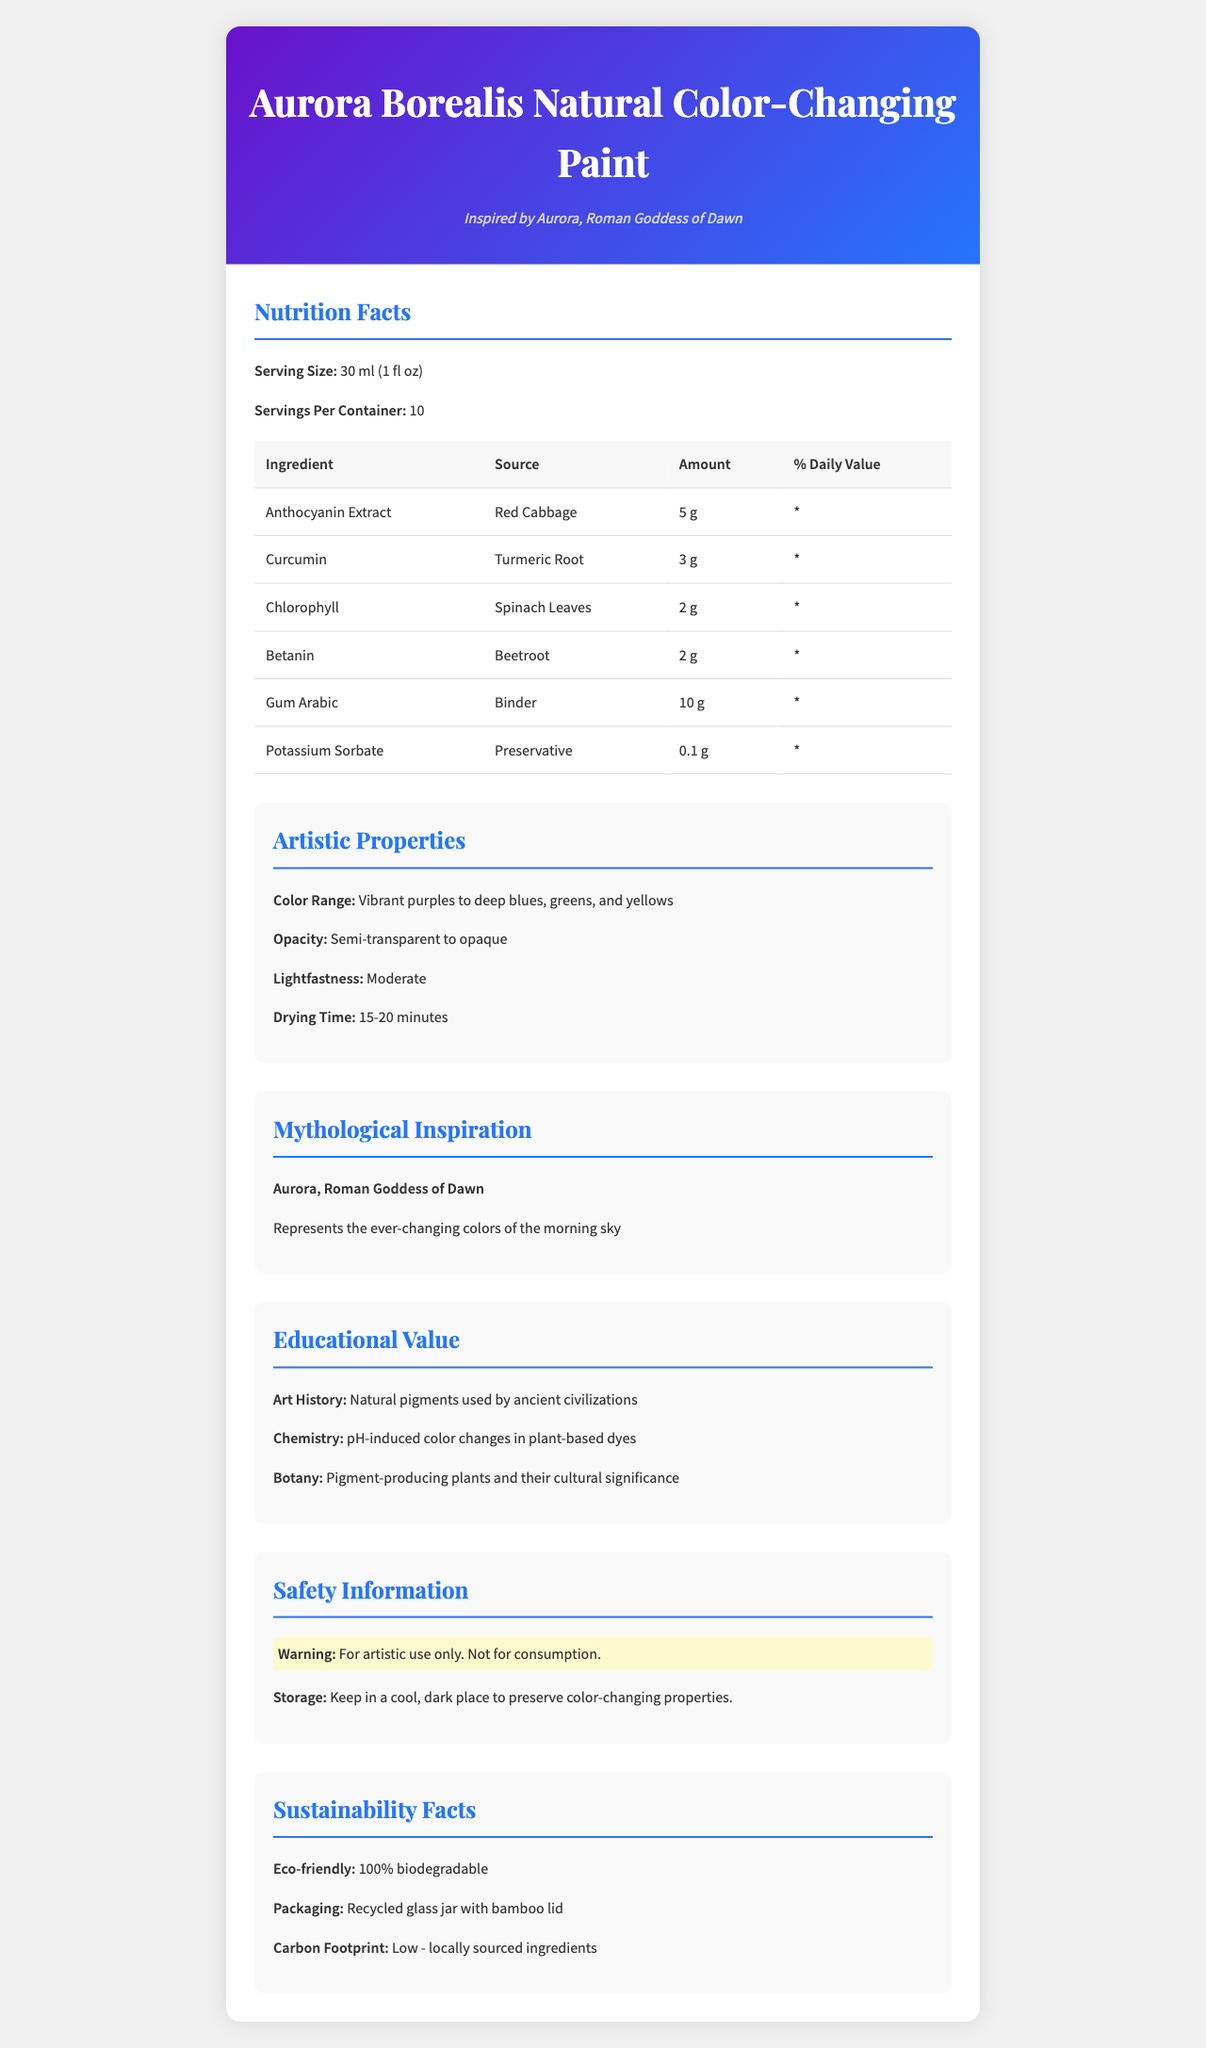what is the serving size? The serving size is explicitly mentioned at the beginning of the document under "Serving Size".
Answer: 30 ml (1 fl oz) how many servings are there per container? The document states the number of servings per container, which is 10.
Answer: 10 name one natural source of the pigment Anthocyanin Extract. The source for Anthocyanin Extract is mentioned as Red Cabbage in the pigment composition table.
Answer: Red Cabbage what is the drying time of the paint? The drying time is listed under "Artistic Properties".
Answer: 15-20 minutes who is the mythological inspiration for the paint? The mythological inspiration is Aurora, the Roman Goddess of Dawn, detailed under "Mythological Inspiration".
Answer: Aurora, Roman Goddess of Dawn which pigment is sourced from Turmeric Root? Curcumin is listed with Turmeric Root as its source in the pigment composition.
Answer: Curcumin what is the main binder used in this paint? Gum Arabic is mentioned as the binder in the pigment composition table.
Answer: Gum Arabic how many grams of Curcumin are in each serving? The amount of Curcumin per serving is 3 g, as listed in the pigment composition.
Answer: 3 g what educational topics are explored through this product? A. Art History B. Chemistry C. Botany D. All of the above The document details educational values in art history, chemistry, and botany.
Answer: D which of the following ingredients is a preservative? A. Citric Acid B. Potassium Sorbate C. Sodium Bicarbonate D. Gum Arabic Potassium Sorbate is listed as the preservative with the amount and percent daily value in the pigment composition.
Answer: B does the document suggest the paint is safe for consumption? The document clearly indicates that the paint is for artistic use only and not for consumption in the "Safety Information" section.
Answer: No summarize the key points of the product description. The paint is noted for its natural pigments and rich educational value, covering art history, chemistry, and botany, and is environmentally friendly with sustainable packaging.
Answer: Aurora Borealis Natural Color-Changing Paint is made from natural pigments such as Anthocyanin Extract, Curcumin, Chlorophyll, and Betanin. It exemplifies artistic properties like a wide color range and a moderate lightfastness. Inspired by Aurora, the Roman Goddess of Dawn, it ties together lessons from art history, chemistry, and botany. Additionally, it is 100% biodegradable and sustainably packaged. how long does the color-changing property last upon storage? The document provides storage instructions but does not specify how long the color-changing properties specifically last.
Answer: Not enough information what should be used for a more eco-friendly painting experience? A. Recycled glass jar with a metal lid B. Plastic container C. Recycled glass jar with a bamboo lid D. Aluminum can The document mentions that the packaging is a recycled glass jar with a bamboo lid, making it eco-friendly.
Answer: C 